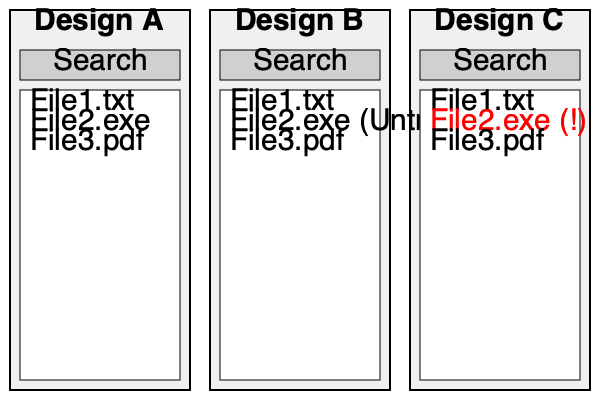Given these three UI mockups for a file explorer, which design best represents the principles of user-centric design and security for a cautious user who prefers manual vigilance over automated security measures? 1. Design A: This is a basic file explorer with no additional security features. It relies entirely on the user's vigilance to identify potentially harmful files.

2. Design B: This design includes a security feature that labels potentially untrusted files. While this adds a layer of automated security, it might be seen as unnecessary for a cautious user who prefers to rely on their own judgment.

3. Design C: This design uses a color-coded system (red) and an exclamation mark to draw attention to potentially harmful files without explicitly labeling them as untrusted. This approach:
   a) Respects the user's preference for manual vigilance by not applying an automatic "untrusted" label.
   b) Provides a subtle yet clear visual cue to prompt the user's attention and caution.
   c) Allows the user to make their own informed decision about the file's trustworthiness.
   d) Balances user-centric design (clear visual cues) with the principle of user responsibility for security.

For an old-school developer who believes in user caution over automated security measures, Design C offers the best compromise. It provides a visual aid to support the user's vigilance without relying on automated labeling or extensive security features.
Answer: Design C 